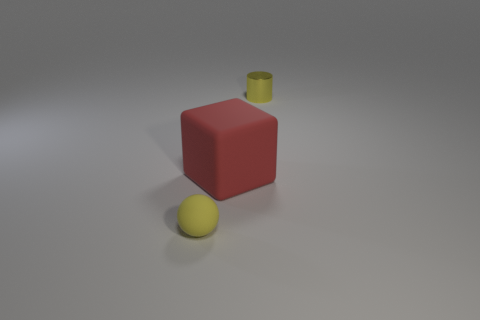Add 1 small cylinders. How many objects exist? 4 Subtract all blocks. How many objects are left? 2 Subtract all large gray rubber balls. Subtract all yellow matte objects. How many objects are left? 2 Add 2 yellow shiny cylinders. How many yellow shiny cylinders are left? 3 Add 1 small cyan metallic spheres. How many small cyan metallic spheres exist? 1 Subtract 0 gray cylinders. How many objects are left? 3 Subtract all green cylinders. Subtract all brown cubes. How many cylinders are left? 1 